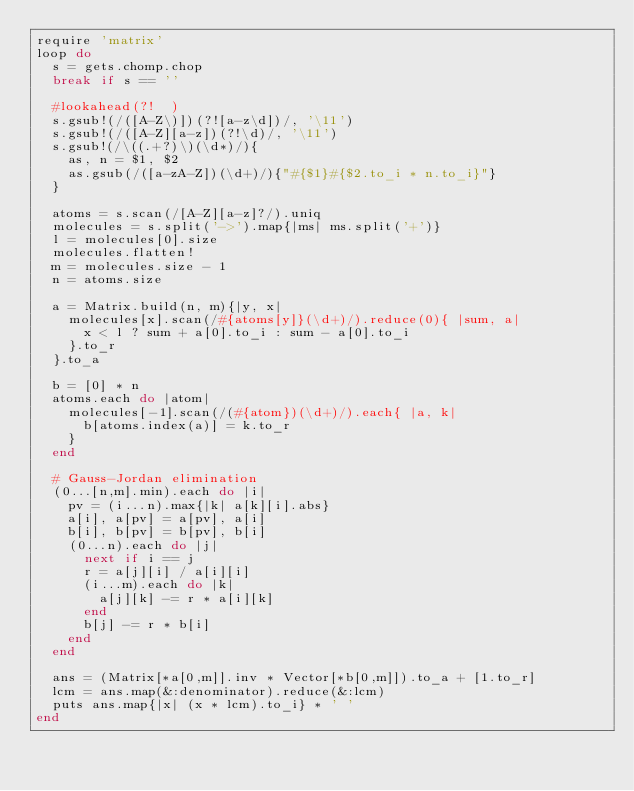<code> <loc_0><loc_0><loc_500><loc_500><_Ruby_>require 'matrix'
loop do
  s = gets.chomp.chop
  break if s == ''

  #lookahead(?!  )
  s.gsub!(/([A-Z\)])(?![a-z\d])/, '\11')
  s.gsub!(/([A-Z][a-z])(?!\d)/, '\11')
  s.gsub!(/\((.+?)\)(\d*)/){
    as, n = $1, $2
    as.gsub(/([a-zA-Z])(\d+)/){"#{$1}#{$2.to_i * n.to_i}"}
  }

  atoms = s.scan(/[A-Z][a-z]?/).uniq
  molecules = s.split('->').map{|ms| ms.split('+')}
  l = molecules[0].size
  molecules.flatten!
  m = molecules.size - 1
  n = atoms.size

  a = Matrix.build(n, m){|y, x|
    molecules[x].scan(/#{atoms[y]}(\d+)/).reduce(0){ |sum, a|
      x < l ? sum + a[0].to_i : sum - a[0].to_i
    }.to_r
  }.to_a

  b = [0] * n
  atoms.each do |atom|
    molecules[-1].scan(/(#{atom})(\d+)/).each{ |a, k|
      b[atoms.index(a)] = k.to_r
    }
  end

  # Gauss-Jordan elimination
  (0...[n,m].min).each do |i|
    pv = (i...n).max{|k| a[k][i].abs}
    a[i], a[pv] = a[pv], a[i]
    b[i], b[pv] = b[pv], b[i]
    (0...n).each do |j|
      next if i == j
      r = a[j][i] / a[i][i]
      (i...m).each do |k|
        a[j][k] -= r * a[i][k]
      end
      b[j] -= r * b[i]
    end
  end

  ans = (Matrix[*a[0,m]].inv * Vector[*b[0,m]]).to_a + [1.to_r]
  lcm = ans.map(&:denominator).reduce(&:lcm)
  puts ans.map{|x| (x * lcm).to_i} * ' '
end</code> 